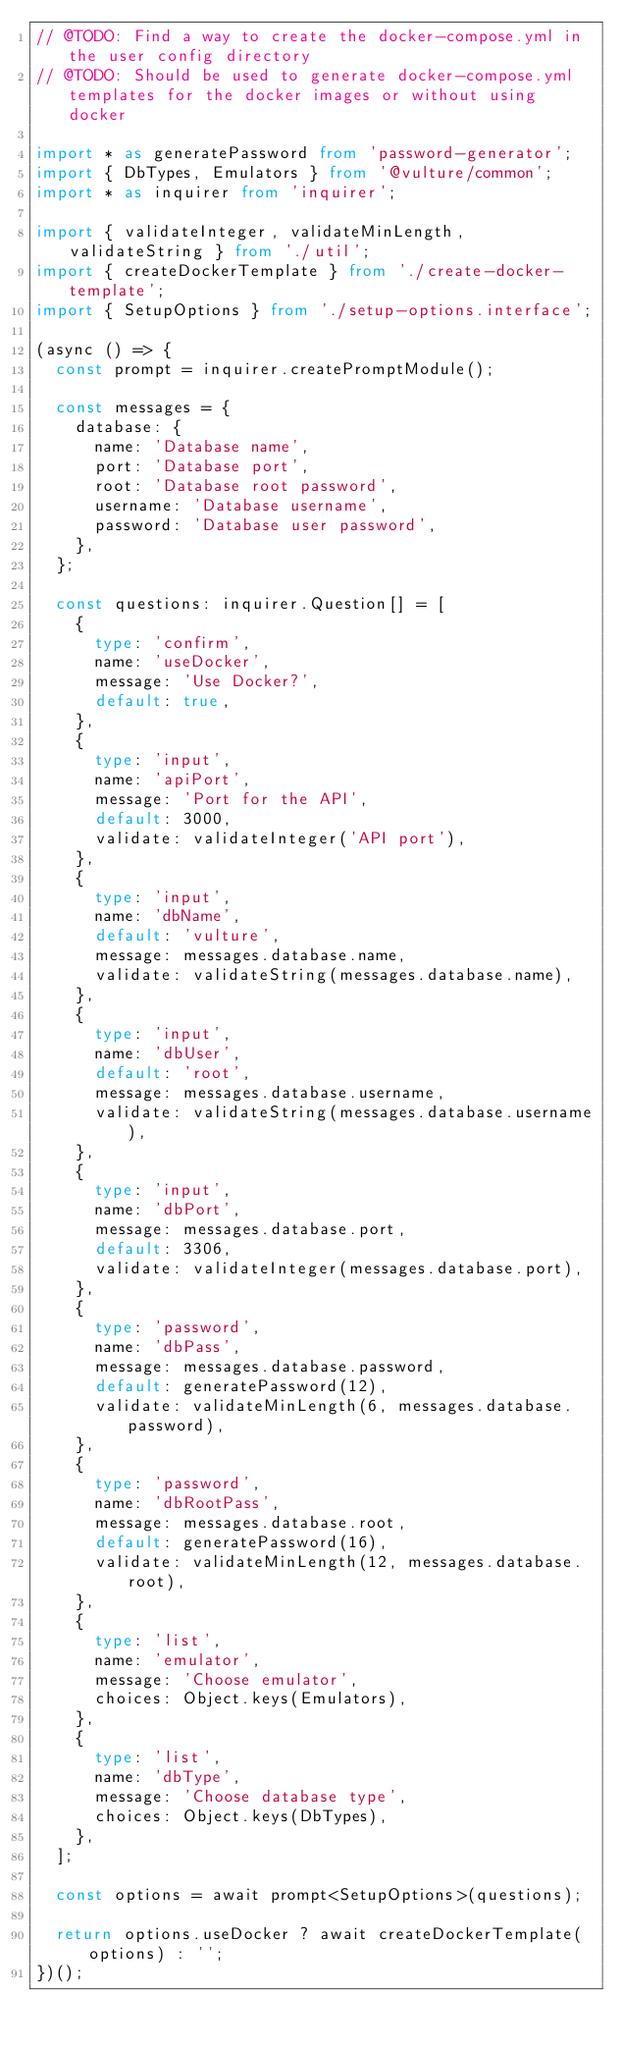<code> <loc_0><loc_0><loc_500><loc_500><_TypeScript_>// @TODO: Find a way to create the docker-compose.yml in the user config directory
// @TODO: Should be used to generate docker-compose.yml templates for the docker images or without using docker

import * as generatePassword from 'password-generator';
import { DbTypes, Emulators } from '@vulture/common';
import * as inquirer from 'inquirer';

import { validateInteger, validateMinLength, validateString } from './util';
import { createDockerTemplate } from './create-docker-template';
import { SetupOptions } from './setup-options.interface';

(async () => {
  const prompt = inquirer.createPromptModule();

  const messages = {
    database: {
      name: 'Database name',
      port: 'Database port',
      root: 'Database root password',
      username: 'Database username',
      password: 'Database user password',
    },
  };

  const questions: inquirer.Question[] = [
    {
      type: 'confirm',
      name: 'useDocker',
      message: 'Use Docker?',
      default: true,
    },
    {
      type: 'input',
      name: 'apiPort',
      message: 'Port for the API',
      default: 3000,
      validate: validateInteger('API port'),
    },
    {
      type: 'input',
      name: 'dbName',
      default: 'vulture',
      message: messages.database.name,
      validate: validateString(messages.database.name),
    },
    {
      type: 'input',
      name: 'dbUser',
      default: 'root',
      message: messages.database.username,
      validate: validateString(messages.database.username),
    },
    {
      type: 'input',
      name: 'dbPort',
      message: messages.database.port,
      default: 3306,
      validate: validateInteger(messages.database.port),
    },
    {
      type: 'password',
      name: 'dbPass',
      message: messages.database.password,
      default: generatePassword(12),
      validate: validateMinLength(6, messages.database.password),
    },
    {
      type: 'password',
      name: 'dbRootPass',
      message: messages.database.root,
      default: generatePassword(16),
      validate: validateMinLength(12, messages.database.root),
    },
    {
      type: 'list',
      name: 'emulator',
      message: 'Choose emulator',
      choices: Object.keys(Emulators),
    },
    {
      type: 'list',
      name: 'dbType',
      message: 'Choose database type',
      choices: Object.keys(DbTypes),
    },
  ];

  const options = await prompt<SetupOptions>(questions);

  return options.useDocker ? await createDockerTemplate(options) : '';
})();
</code> 